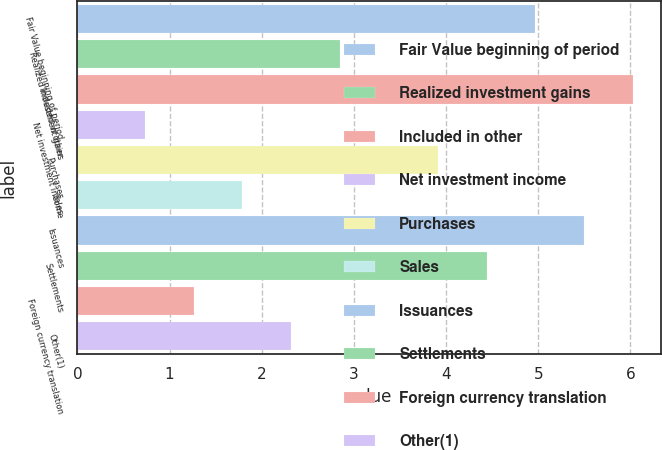Convert chart. <chart><loc_0><loc_0><loc_500><loc_500><bar_chart><fcel>Fair Value beginning of period<fcel>Realized investment gains<fcel>Included in other<fcel>Net investment income<fcel>Purchases<fcel>Sales<fcel>Issuances<fcel>Settlements<fcel>Foreign currency translation<fcel>Other(1)<nl><fcel>4.97<fcel>2.85<fcel>6.03<fcel>0.73<fcel>3.91<fcel>1.79<fcel>5.5<fcel>4.44<fcel>1.26<fcel>2.32<nl></chart> 